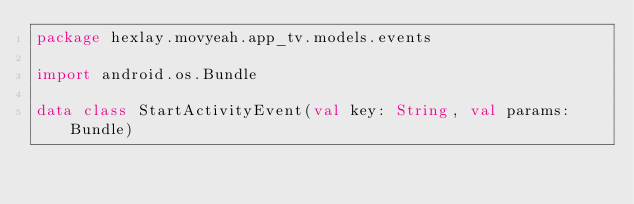<code> <loc_0><loc_0><loc_500><loc_500><_Kotlin_>package hexlay.movyeah.app_tv.models.events

import android.os.Bundle

data class StartActivityEvent(val key: String, val params: Bundle)</code> 